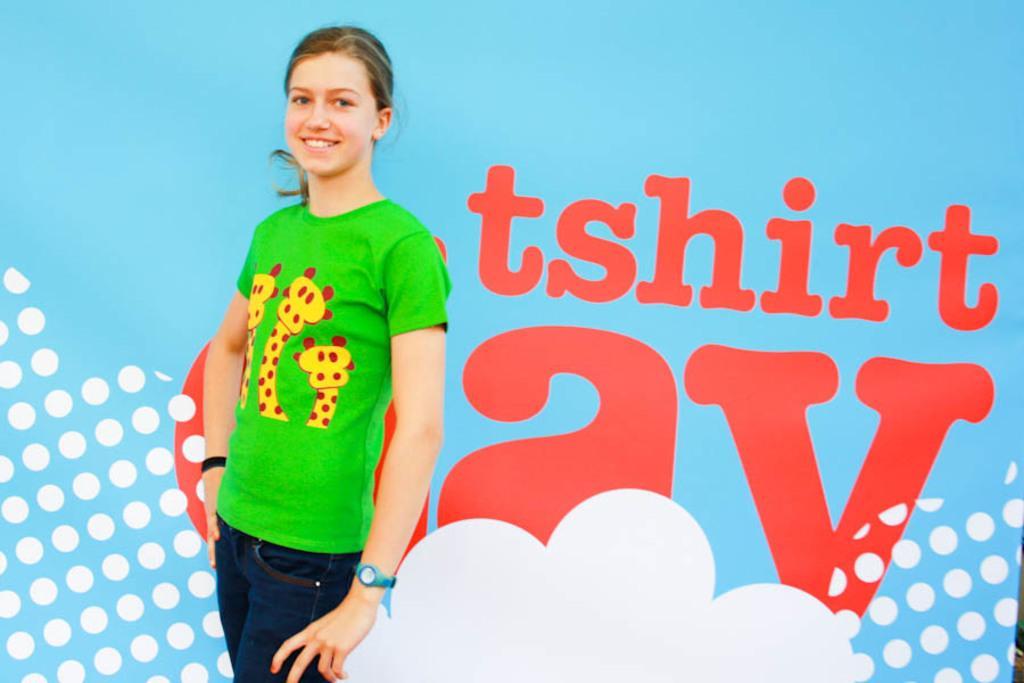Please provide a concise description of this image. In this picture there is a woman standing and smiling, behind her we can see hoarding. 